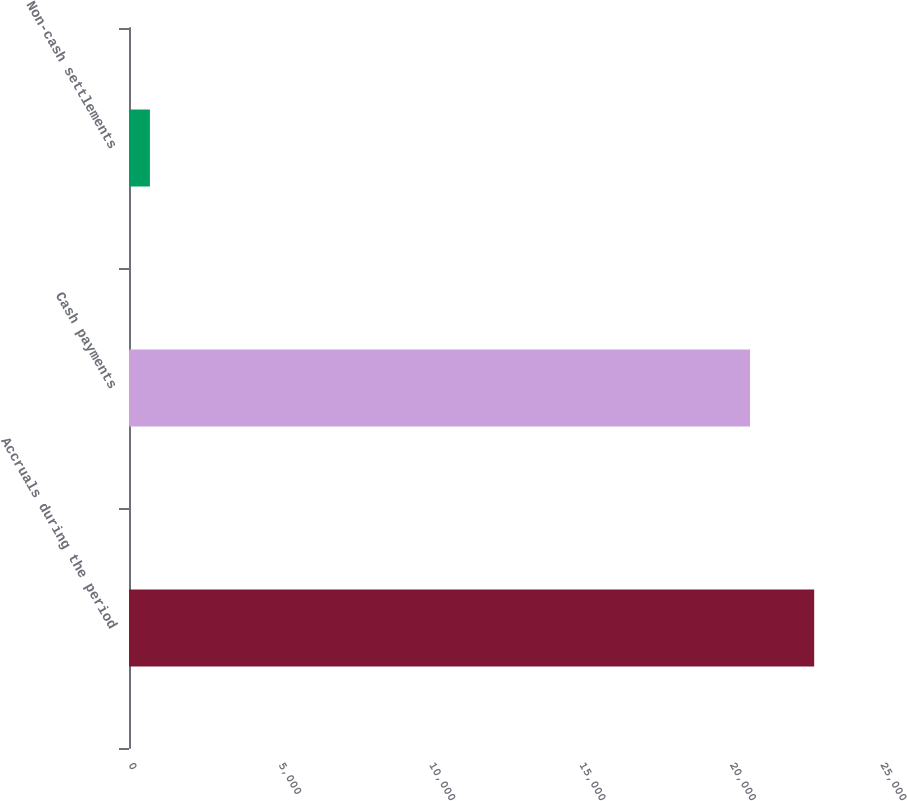Convert chart. <chart><loc_0><loc_0><loc_500><loc_500><bar_chart><fcel>Accruals during the period<fcel>Cash payments<fcel>Non-cash settlements<nl><fcel>22778.8<fcel>20646<fcel>695<nl></chart> 